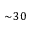<formula> <loc_0><loc_0><loc_500><loc_500>\sim \, 3 0</formula> 